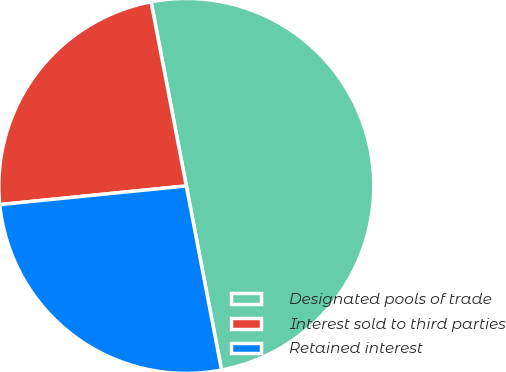<chart> <loc_0><loc_0><loc_500><loc_500><pie_chart><fcel>Designated pools of trade<fcel>Interest sold to third parties<fcel>Retained interest<nl><fcel>50.0%<fcel>23.58%<fcel>26.42%<nl></chart> 